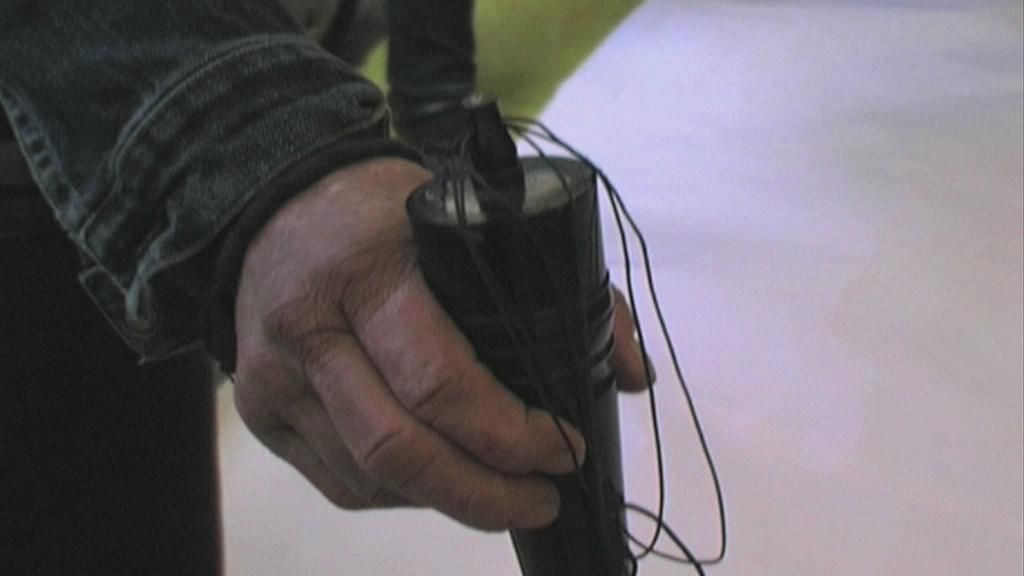What is the human hand holding in the image? The human hand is holding an object in the image, but the specific object is not mentioned in the facts. What colors can be seen in the background of the image? The background of the image has green and white colors. How many legs can be seen in the image? There is no information about legs in the image, as the facts only mention a human hand holding an object and the background colors. 